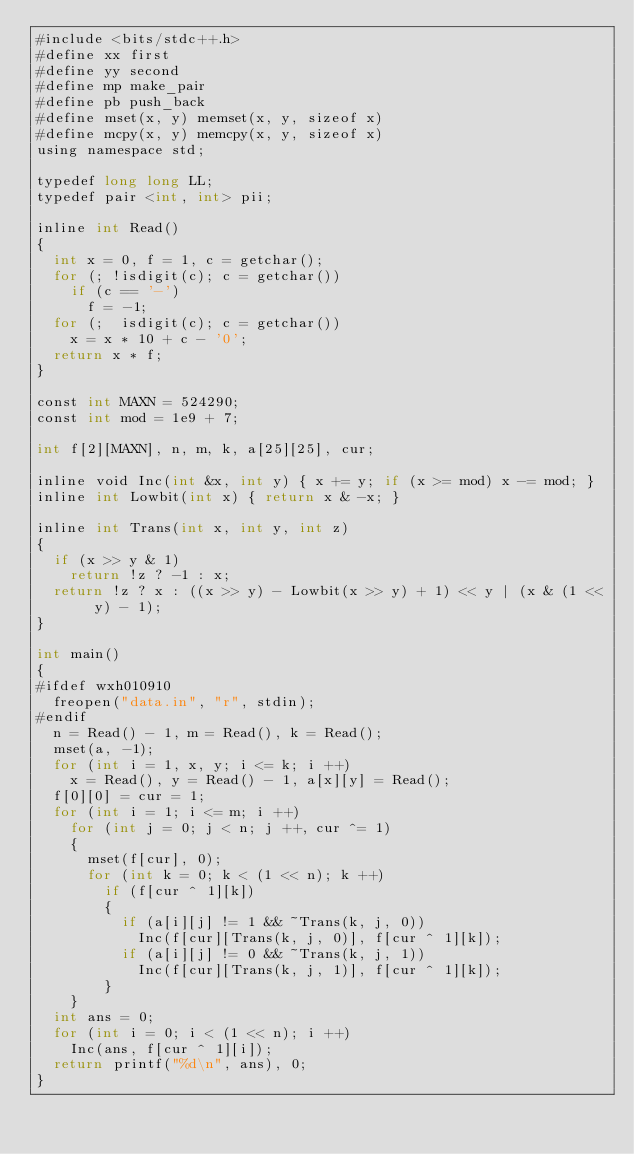<code> <loc_0><loc_0><loc_500><loc_500><_Python_>#include <bits/stdc++.h>
#define xx first
#define yy second
#define mp make_pair
#define pb push_back
#define mset(x, y) memset(x, y, sizeof x)
#define mcpy(x, y) memcpy(x, y, sizeof x)
using namespace std;

typedef long long LL;
typedef pair <int, int> pii;

inline int Read()
{
	int x = 0, f = 1, c = getchar();
	for (; !isdigit(c); c = getchar())
		if (c == '-')
			f = -1;
	for (;  isdigit(c); c = getchar())
		x = x * 10 + c - '0';
	return x * f;
}

const int MAXN = 524290;
const int mod = 1e9 + 7;

int f[2][MAXN], n, m, k, a[25][25], cur;

inline void Inc(int &x, int y) { x += y; if (x >= mod) x -= mod; }
inline int Lowbit(int x) { return x & -x; }

inline int Trans(int x, int y, int z)
{
	if (x >> y & 1)
		return !z ? -1 : x;
	return !z ? x : ((x >> y) - Lowbit(x >> y) + 1) << y | (x & (1 << y) - 1);
}

int main()
{
#ifdef wxh010910
	freopen("data.in", "r", stdin);
#endif
	n = Read() - 1, m = Read(), k = Read();
	mset(a, -1);
	for (int i = 1, x, y; i <= k; i ++)
		x = Read(), y = Read() - 1, a[x][y] = Read();
	f[0][0] = cur = 1;
	for (int i = 1; i <= m; i ++)
		for (int j = 0; j < n; j ++, cur ^= 1)
		{
			mset(f[cur], 0);
			for (int k = 0; k < (1 << n); k ++)
				if (f[cur ^ 1][k])
				{
					if (a[i][j] != 1 && ~Trans(k, j, 0))
						Inc(f[cur][Trans(k, j, 0)], f[cur ^ 1][k]);
					if (a[i][j] != 0 && ~Trans(k, j, 1))
						Inc(f[cur][Trans(k, j, 1)], f[cur ^ 1][k]);
				}
		}
	int ans = 0;
	for (int i = 0; i < (1 << n); i ++)
		Inc(ans, f[cur ^ 1][i]);
	return printf("%d\n", ans), 0;
}
</code> 